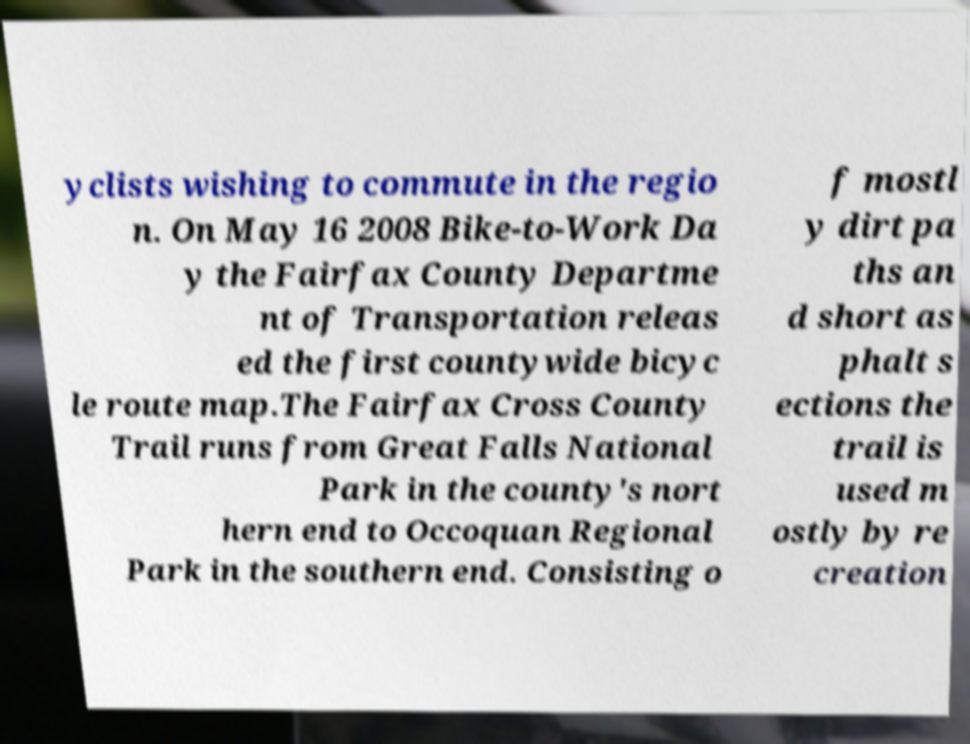Can you read and provide the text displayed in the image?This photo seems to have some interesting text. Can you extract and type it out for me? yclists wishing to commute in the regio n. On May 16 2008 Bike-to-Work Da y the Fairfax County Departme nt of Transportation releas ed the first countywide bicyc le route map.The Fairfax Cross County Trail runs from Great Falls National Park in the county's nort hern end to Occoquan Regional Park in the southern end. Consisting o f mostl y dirt pa ths an d short as phalt s ections the trail is used m ostly by re creation 